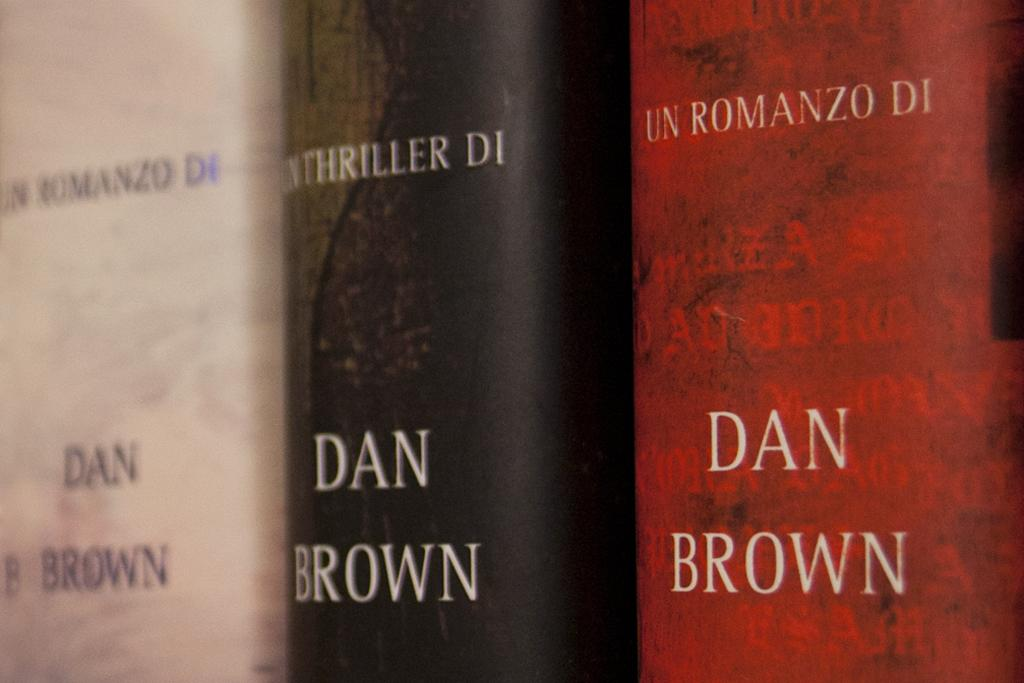Provide a one-sentence caption for the provided image. Three Dan brown thriller books in a line. 